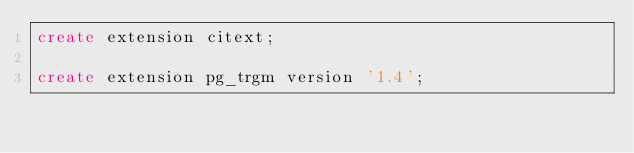<code> <loc_0><loc_0><loc_500><loc_500><_SQL_>create extension citext;

create extension pg_trgm version '1.4';
</code> 